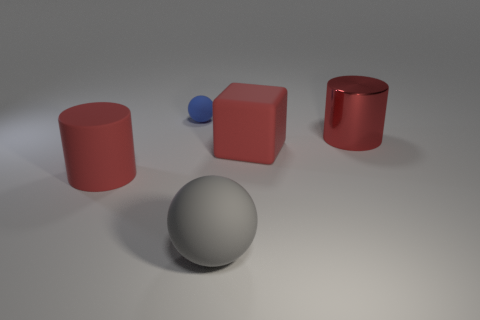Add 4 small objects. How many objects exist? 9 Subtract 1 blocks. How many blocks are left? 0 Subtract all purple balls. How many green cubes are left? 0 Subtract all metallic cylinders. Subtract all large metal cylinders. How many objects are left? 3 Add 1 tiny blue rubber objects. How many tiny blue rubber objects are left? 2 Add 4 tiny cyan matte cylinders. How many tiny cyan matte cylinders exist? 4 Subtract 0 cyan cylinders. How many objects are left? 5 Subtract all blocks. How many objects are left? 4 Subtract all red spheres. Subtract all yellow cubes. How many spheres are left? 2 